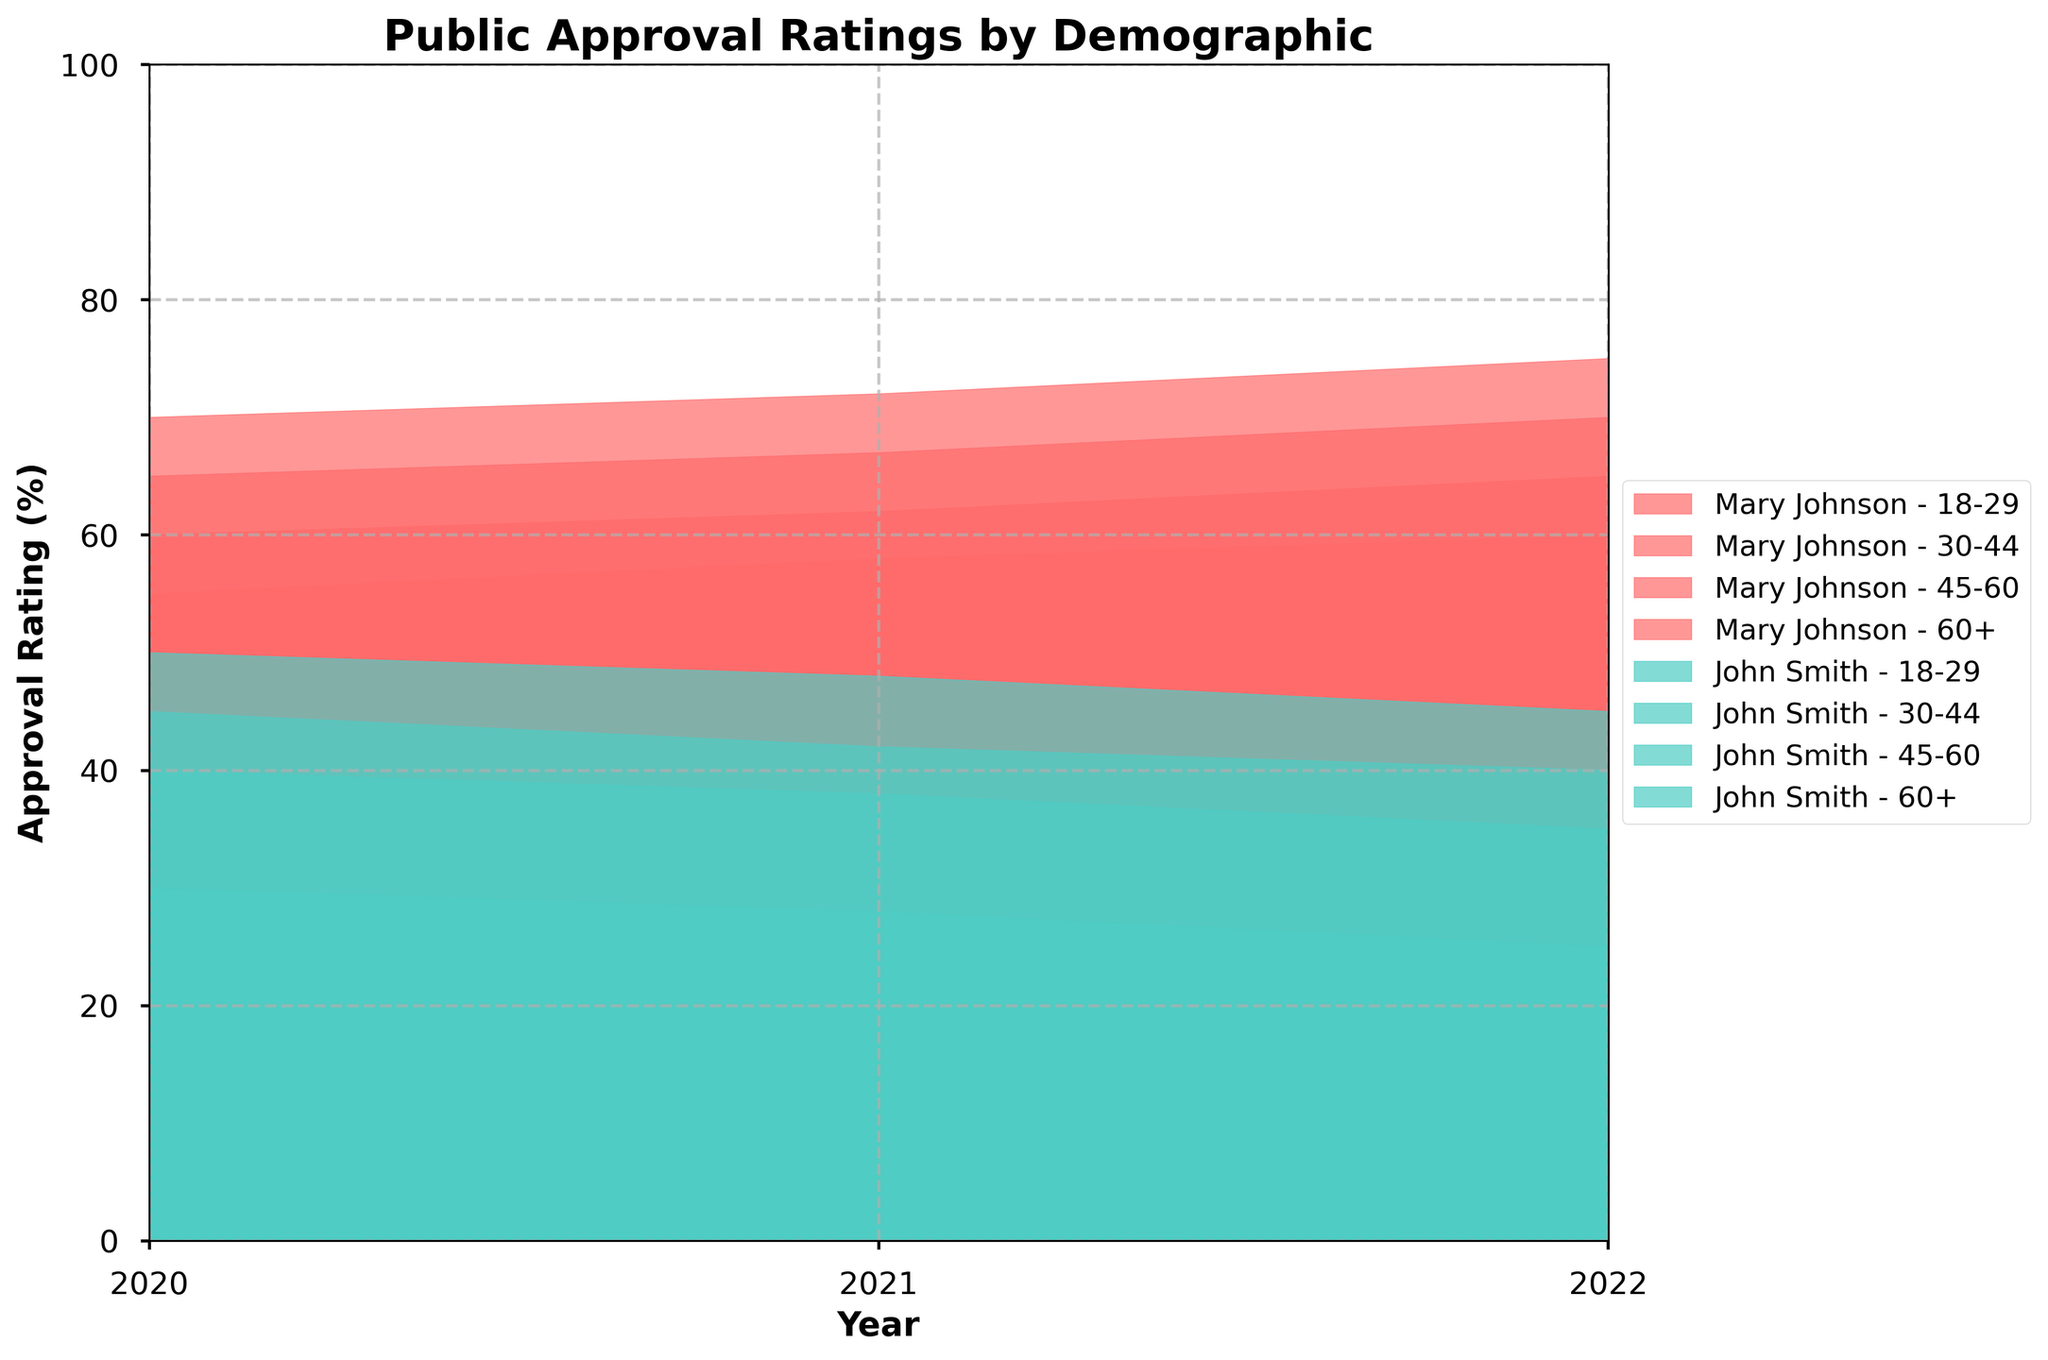What is the title of the figure? The title is generally displayed at the top of the figure and summarizes the content in a few words.
Answer: Public Approval Ratings by Demographic How many demographic groups are represented in the figure? By examining the labels in the legend or on the x-axis or within the plot areas, you can count the number of demographic groups.
Answer: Four groups What are the approval rating ranges on the y-axis? The y-axis in the figure represents approval ratings, typically scaled to show the full range of values present in the data. From the visualization, you observe the range on the side of the plot.
Answer: 0 to 100 Which demographic group shows the highest approval rating for Mary Johnson in 2022? To answer this, look at the areas filled for Mary Johnson and identify the demographic for the peak value in 2022.
Answer: 60+ Compare the trend of John Smith's approval ratings in the 18-29 age group between 2020 and 2022. By observing the filled areas for John Smith specifically in the 18-29 group, track how the approval ratings change over the years. Note the start and end points.
Answer: Decreased from 45 to 40 What is the average approval rating of Mary Johnson in the 45-60 age group over the three years? To find the average, note the values for Mary Johnson in the 45-60 group across the years (65, 67, 70), sum them, and divide by 3.
Answer: (65+67+70)/3 = 67.33 Compare the 2021 approval ratings of Mary Johnson and John Smith for the 30-44 age group. Who had a higher rating? Look at the filled areas for both politicians in the 30-44 age group for 2021 and identify the higher value.
Answer: Mary Johnson Which politician's approval ratings showed the most significant decline in the 60+ age group from 2020 to 2022? Compare the start and end approval ratings for both John Smith and Mary Johnson in the 60+ category and determine the largest negative change.
Answer: John Smith What is the total approval rating for John Smith in the 18-29 demographic over the years presented? Add up approval ratings for John Smith in the 18-29 age group for each year (45, 42, 40).
Answer: 45 + 42 + 40 = 127 Which age demographic shows the most steady approval rating for both politicians over the years? By observing the lines and filled areas for both politicians across demographics, identify the demographic with the least fluctuation.
Answer: 30-44 